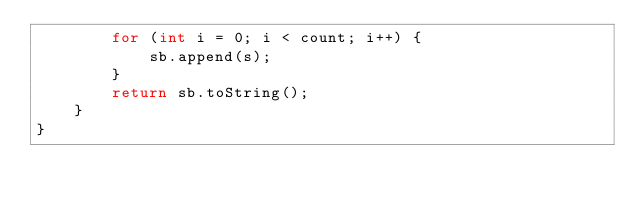<code> <loc_0><loc_0><loc_500><loc_500><_Java_>        for (int i = 0; i < count; i++) {
            sb.append(s);
        }
        return sb.toString();
    }
}
</code> 